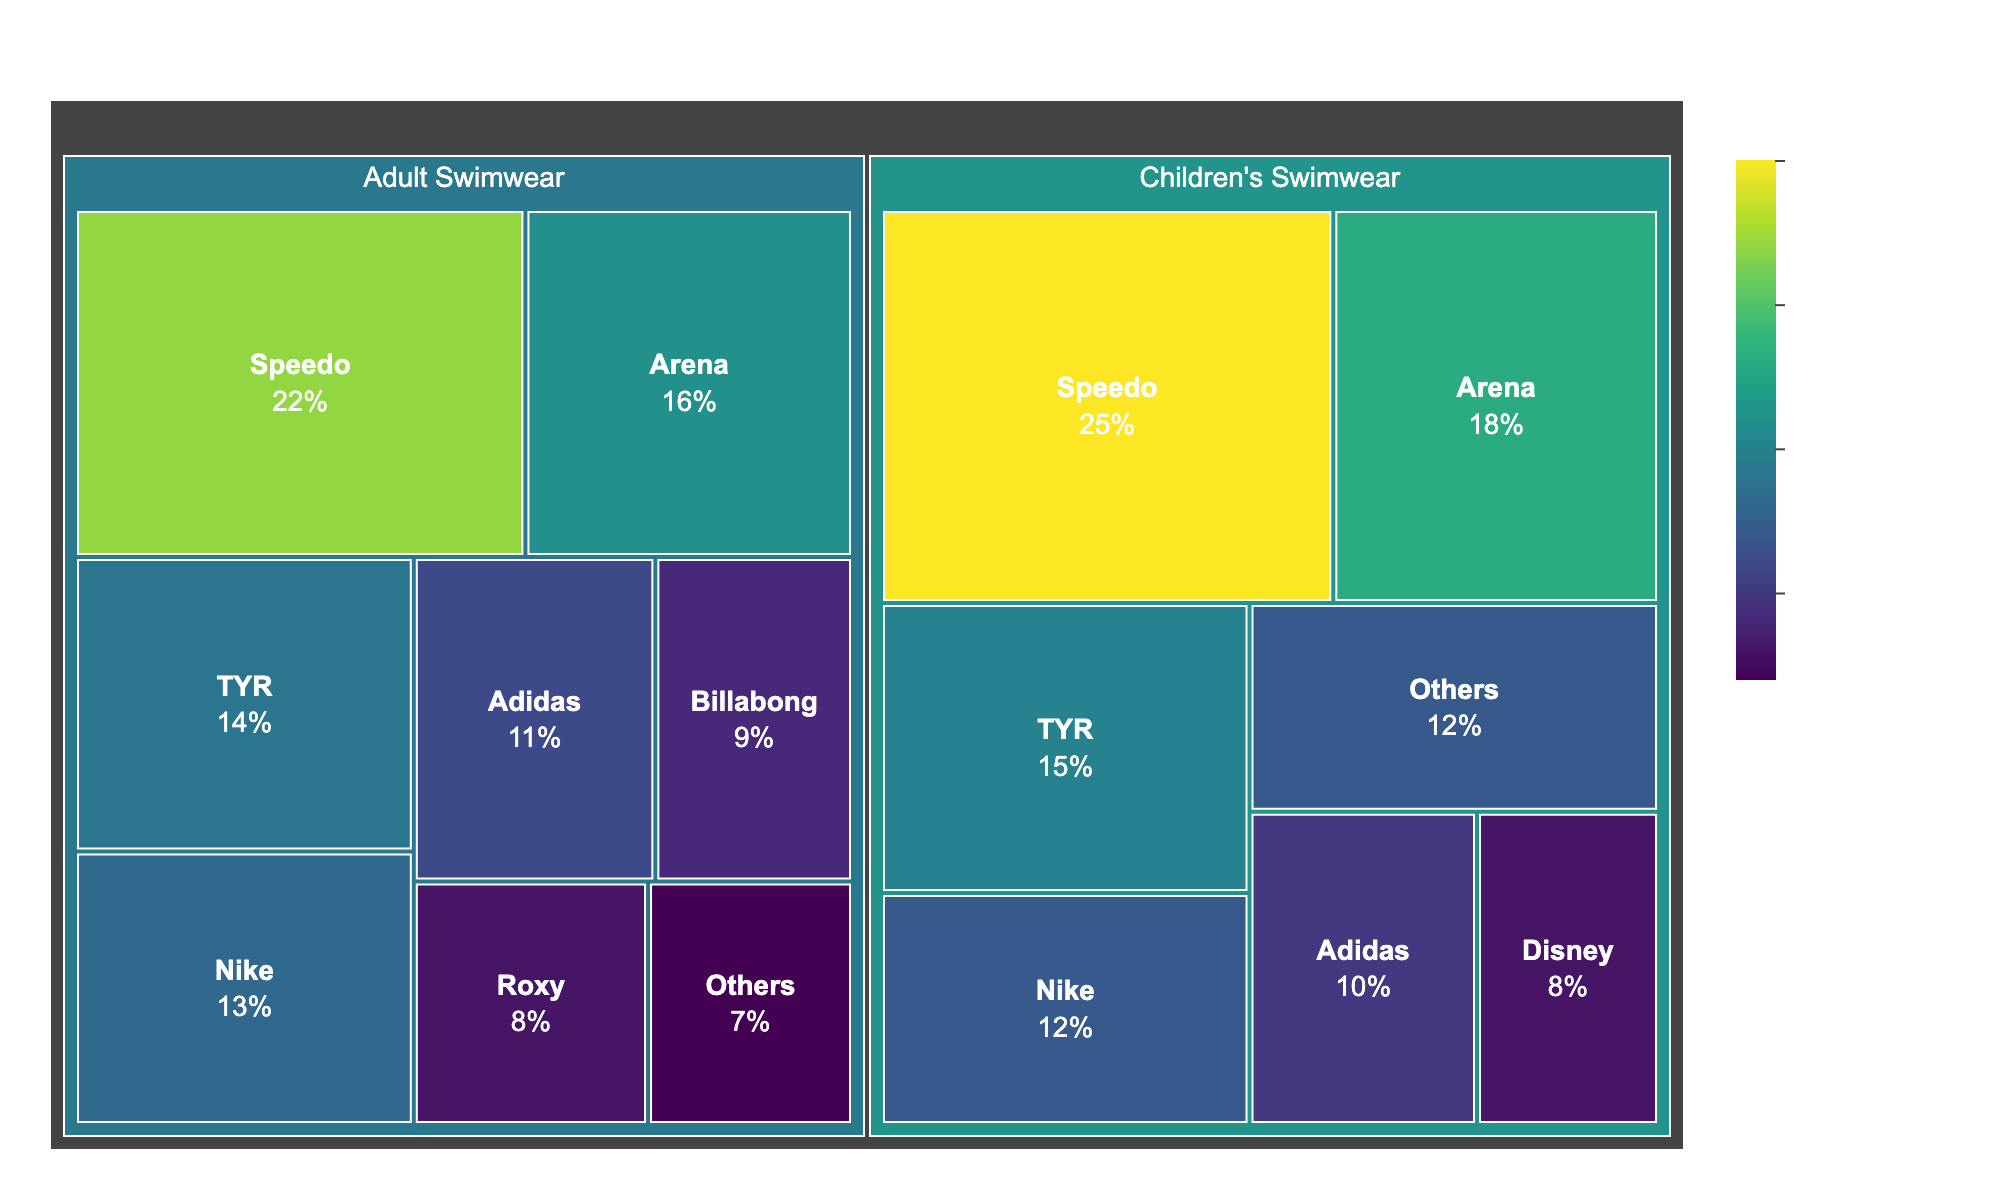What is the title of the treemap? The title can be found at the top of the treemap figure.
Answer: Swimwear Market Share for Children and Adults Which brand has the highest market share in children's swimwear? Look for the brand with the largest area within the children's swimwear category on the treemap.
Answer: Speedo How does the market share of Speedo compare between children's and adult swimwear? Compare the market shares of Speedo in both categories by identifying their values in the respective sections.
Answer: Children's Swimwear: 25%, Adult Swimwear: 22% What's the combined market share of Arena for both children's and adult's swimwear? Sum the market share percentages of Arena from both categories. Arena (Children's Swimwear): 18%, Arena (Adult Swimwear): 16%, combined: 18% + 16% = 34%
Answer: 34% What is the market share of "Others" in adult swimwear? Find the section labeled "Others" within the adult swimwear category.
Answer: 7% Which brand has the lowest market share in children's swimwear? Identify the smallest labeled section within the children's swimwear category.
Answer: Disney How is the market share distributed among smaller brands labeled as "Others" in both categories? Add the market shares of the "Others" category from both children’s and adult’s sections. Children's Others: 12%, Adult's Others: 7%, combined: 12% + 7% = 19%
Answer: 19% Between Billabong and Roxy, which brand has a larger market share in adult swimwear? Compare the market share values for Billabong and Roxy within the adult swimwear category.
Answer: Billabong What proportion of the total swimwear market for adults is held by Nike and Adidas combined? Add the market share percentages of Nike and Adidas in the adult swimwear category. Nike: 13%, Adidas: 11%, combined: 13% + 11% = 24%
Answer: 24% 